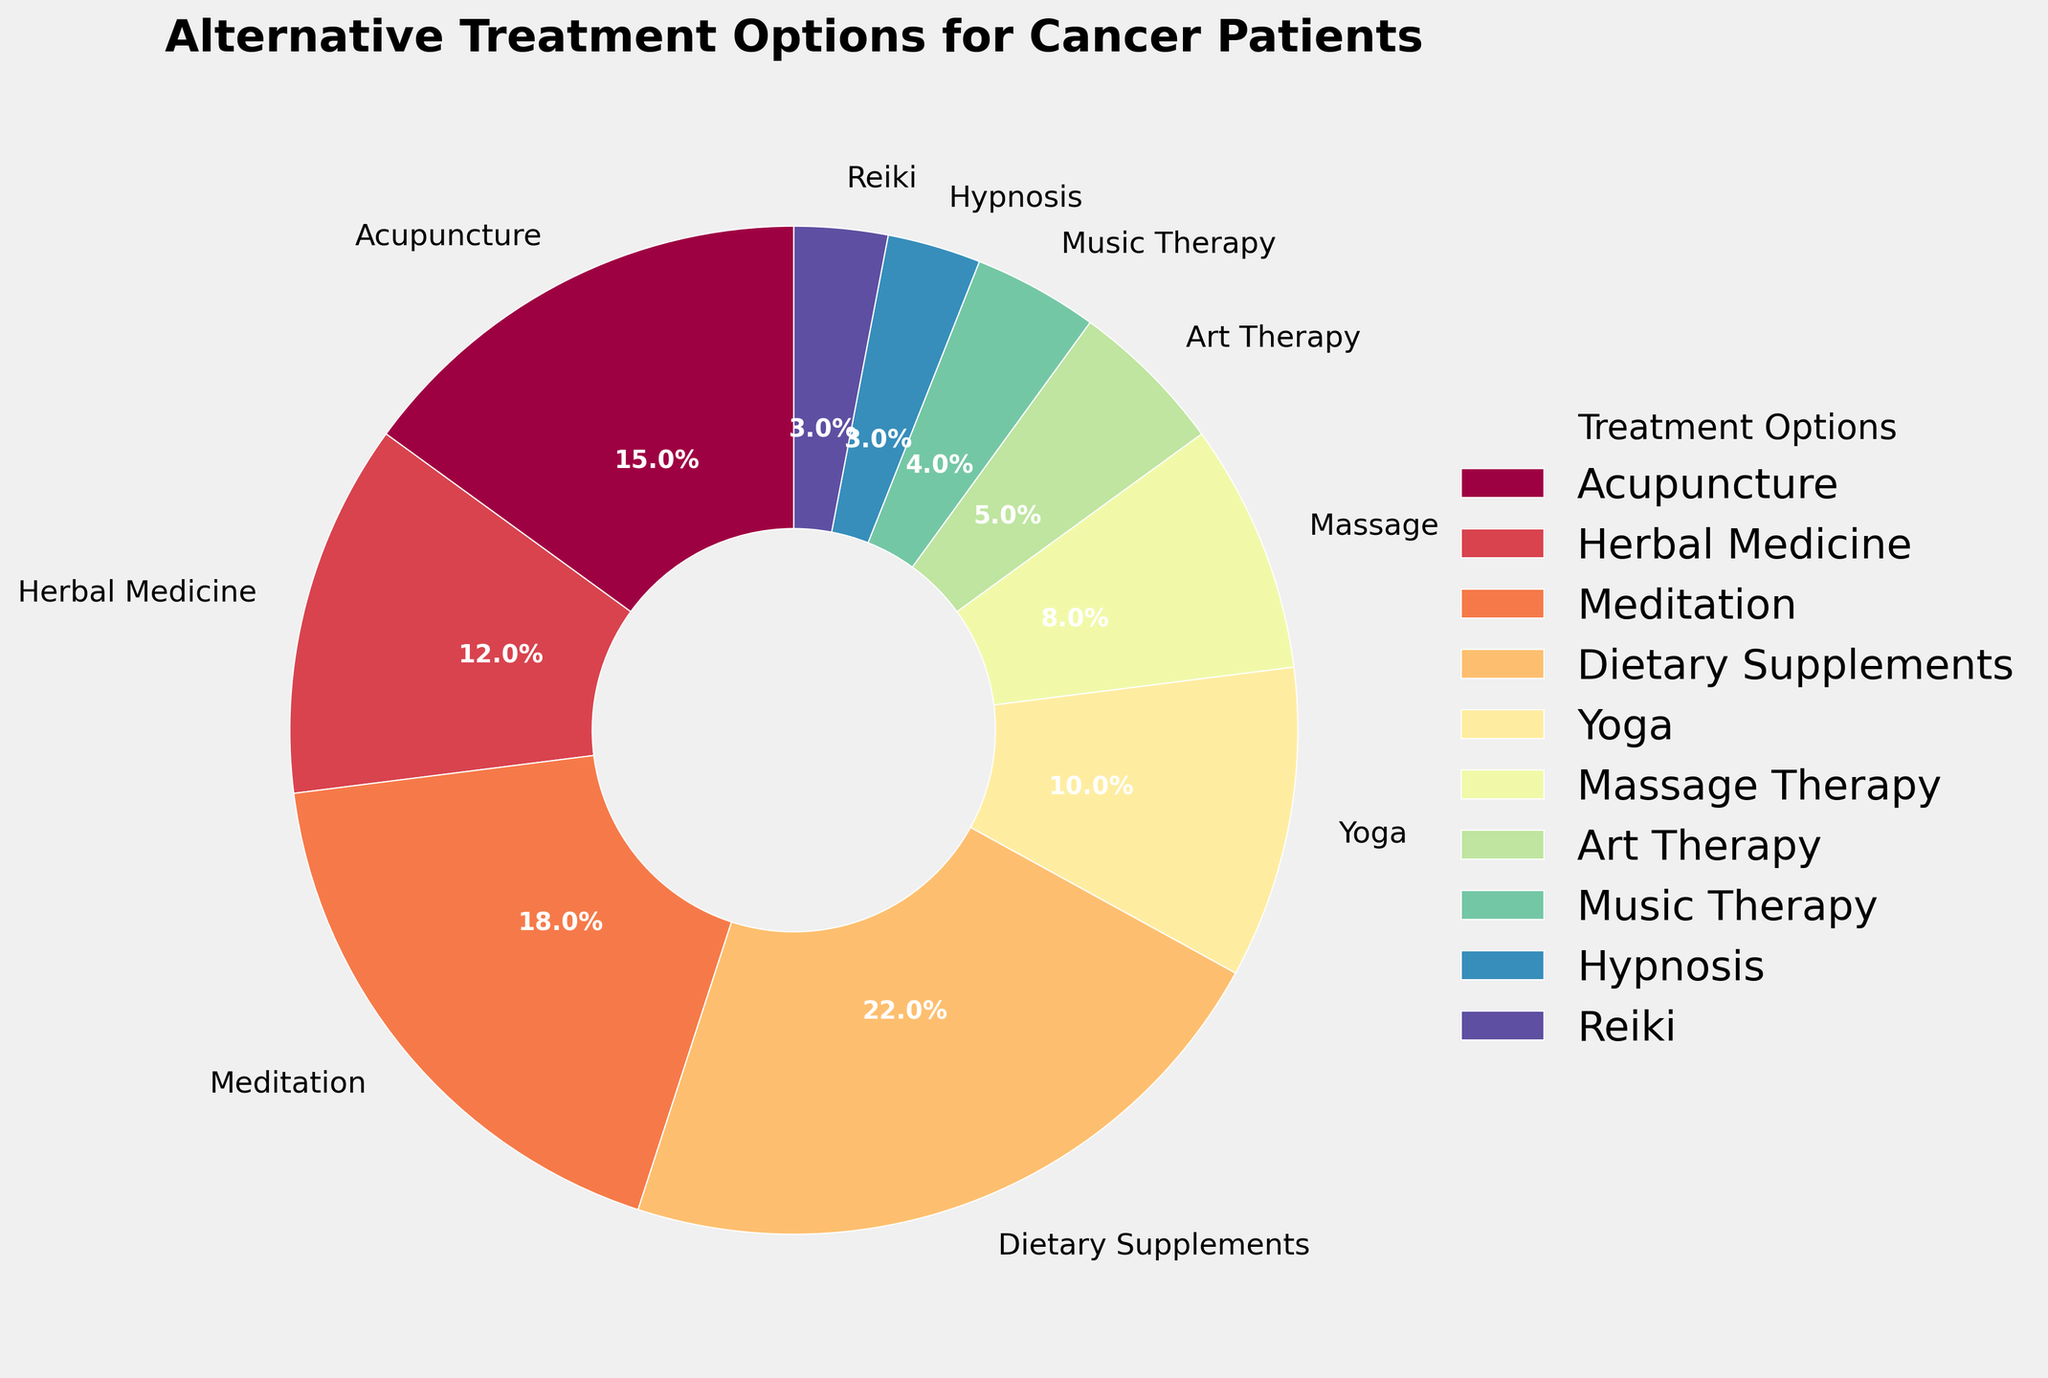Which alternative treatment option has the highest percentage of patients opting for it? From the pie chart, the size of each slice visually indicates the percentage. The largest slice corresponds to Dietary Supplements at 22%.
Answer: Dietary Supplements Which treatment option has the smallest percentage of patients opting for it? By examining the pie chart, the smallest slice corresponds to Hypnosis and Reiki, each at 3%.
Answer: Hypnosis, Reiki What is the percentage difference between the highest and lowest treatment options? The highest percentage is for Dietary Supplements at 22%, and the lowest is for Hypnosis and Reiki, each at 3%. The difference is 22% - 3% = 19%.
Answer: 19% What is the combined percentage of patients opting for Meditation and Yoga? Meditation has a percentage of 18% and Yoga has 10%. The combined percentage is 18% + 10% = 28%.
Answer: 28% How many treatment options have a percentage less than 10%? From the chart, the options with less than 10% are Massage Therapy (8%), Art Therapy (5%), Music Therapy (4%), Hypnosis (3%), and Reiki (3%). There are 5 such options.
Answer: 5 Which treatment options have an equal percentage of patients opting for them? The pie chart shows that Hypnosis and Reiki each have 3%.
Answer: Hypnosis, Reiki What is the total percentage of all treatment options combined? Since the pie chart represents all possible options, the total percentage should sum up to 100%.
Answer: 100% Which color represents Acupuncture in the pie chart? Observing the color legend in the pie chart, Acupuncture corresponds to a distinct color among the segments. You can identify this by matching the label "Acupuncture" with its respective slice.
Answer: [Answer depends on the provided chart, e.g., Yellow, Blue etc.] How much more popular is Meditation compared to Art Therapy? Meditation has 18% and Art Therapy has 5%. The difference is 18% - 5% = 13%.
Answer: 13% Is the percentage of patients opting for Herbal Medicine greater than those opting for Yoga? Herbal Medicine has 12%, while Yoga has 10%. Since 12% > 10%, Herbal Medicine has a higher percentage.
Answer: Yes 